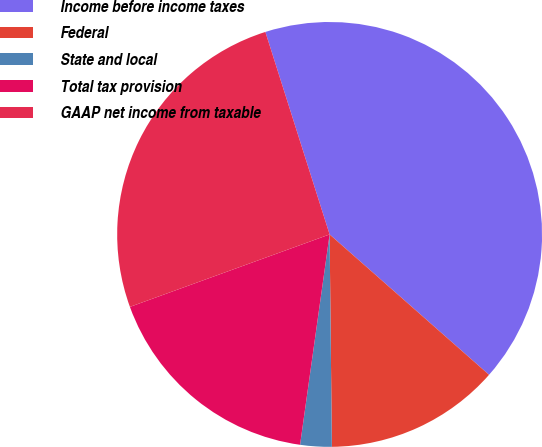<chart> <loc_0><loc_0><loc_500><loc_500><pie_chart><fcel>Income before income taxes<fcel>Federal<fcel>State and local<fcel>Total tax provision<fcel>GAAP net income from taxable<nl><fcel>41.38%<fcel>13.34%<fcel>2.39%<fcel>17.24%<fcel>25.65%<nl></chart> 